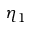Convert formula to latex. <formula><loc_0><loc_0><loc_500><loc_500>\eta _ { 1 }</formula> 